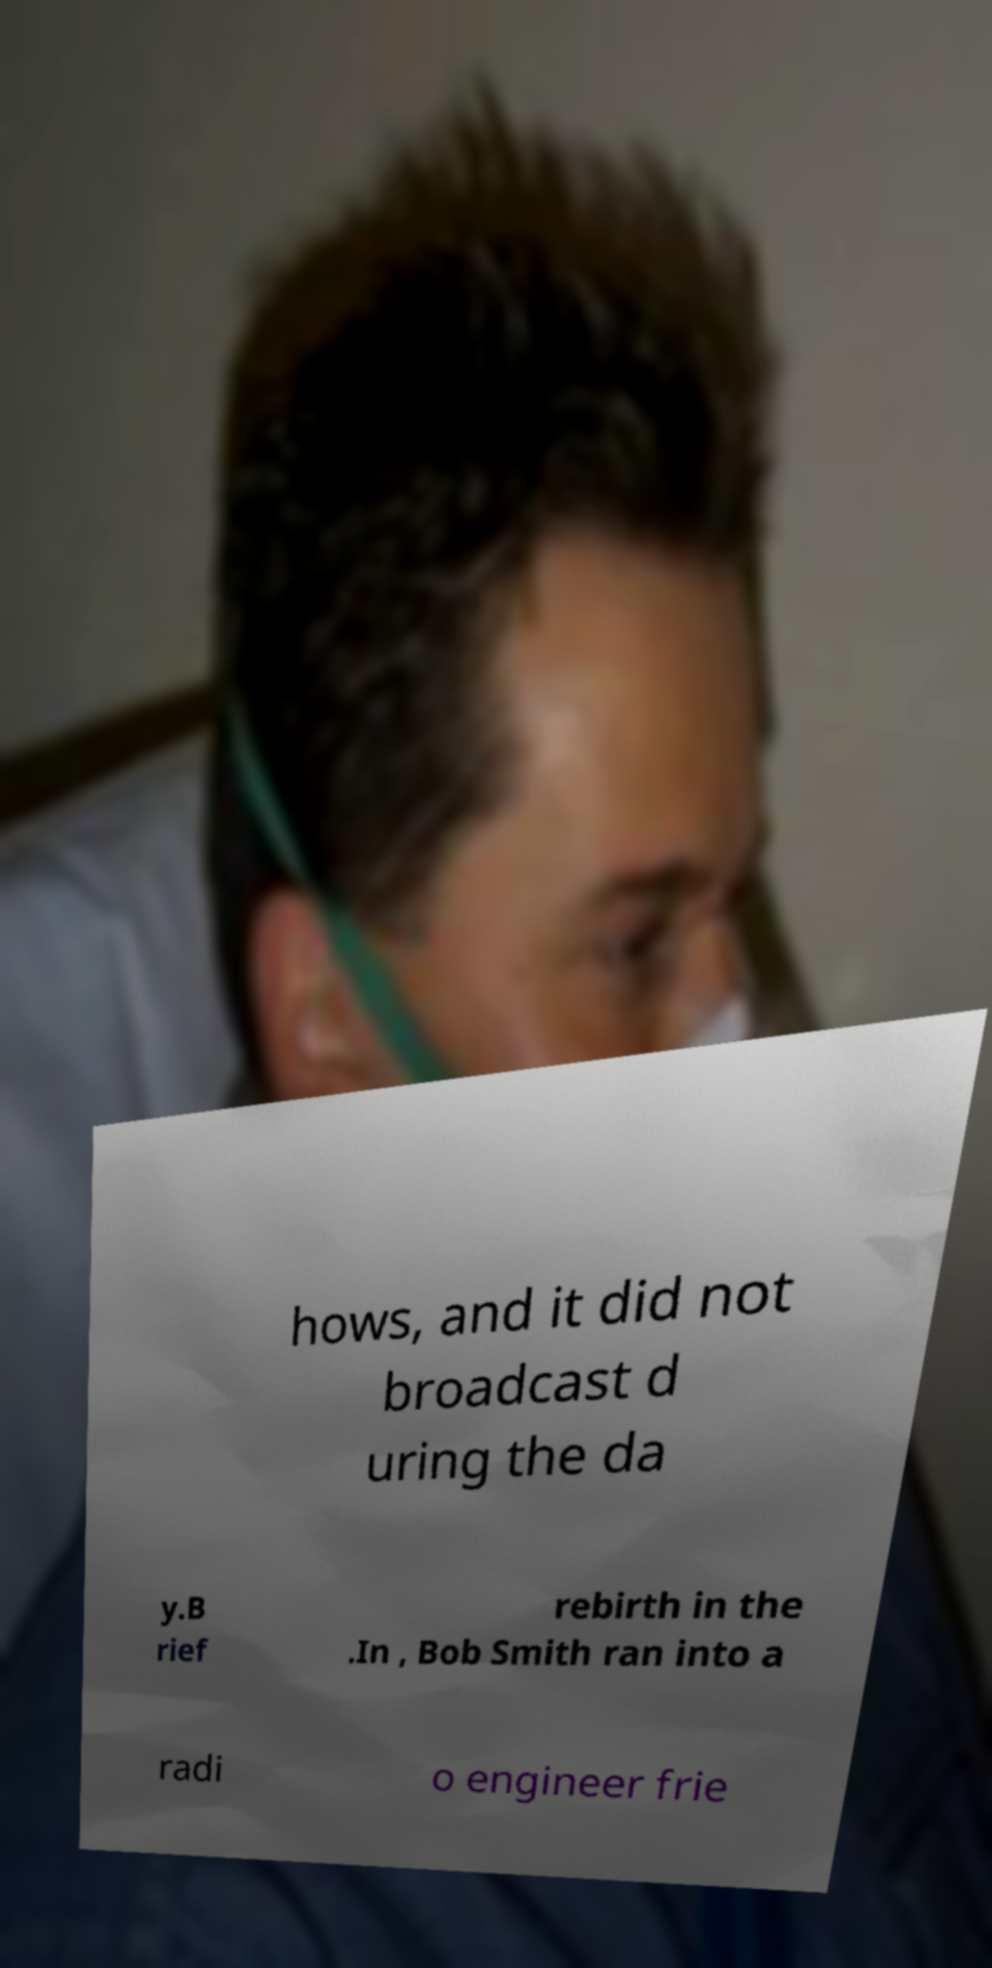Could you assist in decoding the text presented in this image and type it out clearly? hows, and it did not broadcast d uring the da y.B rief rebirth in the .In , Bob Smith ran into a radi o engineer frie 